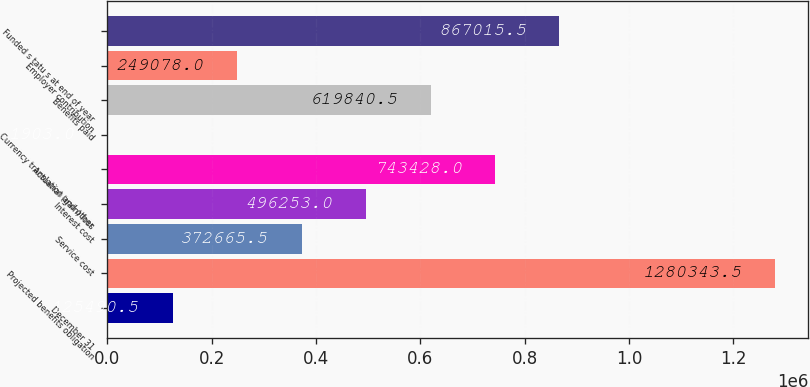Convert chart to OTSL. <chart><loc_0><loc_0><loc_500><loc_500><bar_chart><fcel>December 31<fcel>Projected benefits obligation<fcel>Service cost<fcel>Interest cost<fcel>Actuarial (gain) loss<fcel>Currency translation and other<fcel>Benefits paid<fcel>Employer contribution<fcel>Funded s tatu s at end of year<nl><fcel>125490<fcel>1.28034e+06<fcel>372666<fcel>496253<fcel>743428<fcel>1903<fcel>619840<fcel>249078<fcel>867016<nl></chart> 